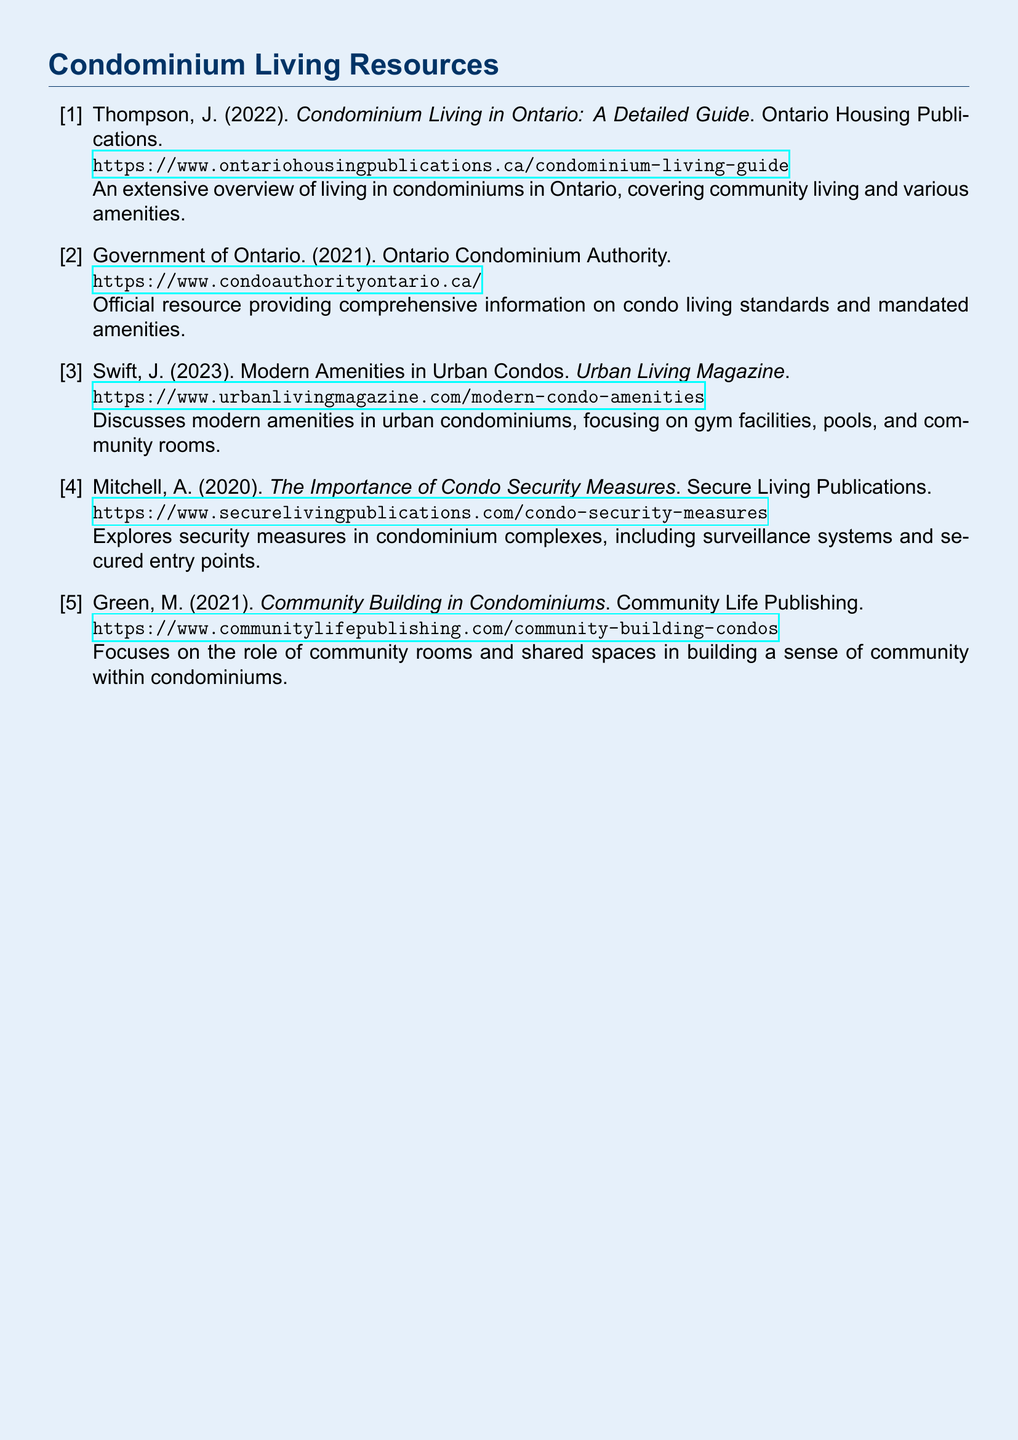What is the title of the document by Thompson? The title of Thompson's document is a direct reference within the bibliography.
Answer: Condominium Living in Ontario: A Detailed Guide What year was the Government of Ontario publication released? The publication year is stated directly next to the author's name in the bibliography.
Answer: 2021 How many publications in the bibliography focus on community aspects in condos? The number of publications is derived from the titles that address community living specifically.
Answer: 2 What is the primary focus of Swift's article? The focus is explicitly mentioned in the title of the article included in the bibliography.
Answer: Modern amenities Who published the document on condo security measures? The name of the publisher is included directly in the bibliographic entry.
Answer: Secure Living Publications What type of amenities does the publication by Swift discuss? The types of amenities are explicitly stated in the summary of Swift's document.
Answer: Gym facilities, pools, and community rooms Which document specifically addresses community rooms? The specific document is identified based on the title and its description in the bibliography.
Answer: Community Building in Condominiums What is the URL for the Ontario Condominium Authority? The URL is directly listed in the bibliographic entry for easy access.
Answer: https://www.condoauthorityontario.ca/ What type of publication is "Urban Living Magazine"? The format is indicated within the citation that includes the title and regulatory context.
Answer: Magazine 